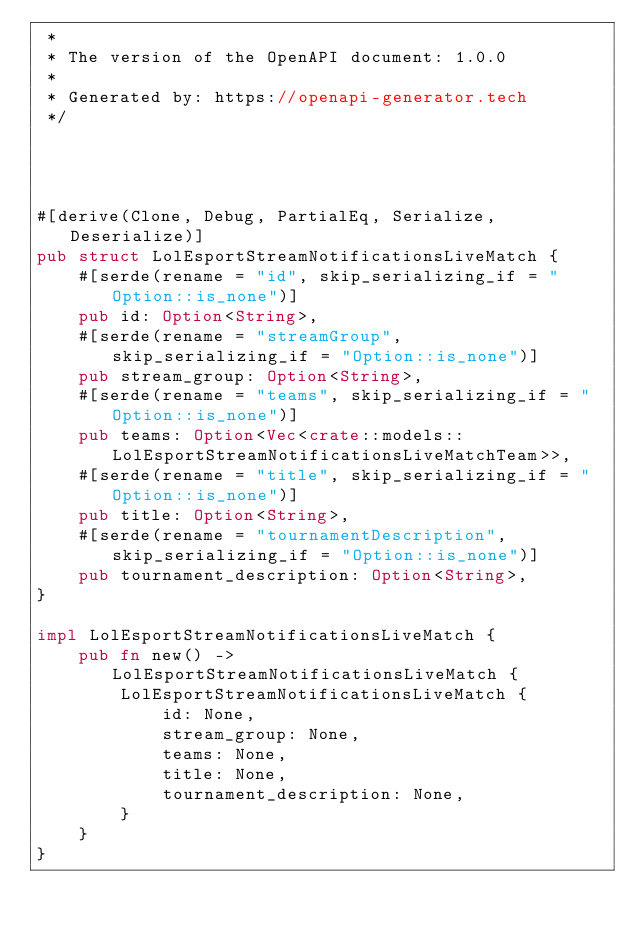<code> <loc_0><loc_0><loc_500><loc_500><_Rust_> *
 * The version of the OpenAPI document: 1.0.0
 * 
 * Generated by: https://openapi-generator.tech
 */




#[derive(Clone, Debug, PartialEq, Serialize, Deserialize)]
pub struct LolEsportStreamNotificationsLiveMatch {
    #[serde(rename = "id", skip_serializing_if = "Option::is_none")]
    pub id: Option<String>,
    #[serde(rename = "streamGroup", skip_serializing_if = "Option::is_none")]
    pub stream_group: Option<String>,
    #[serde(rename = "teams", skip_serializing_if = "Option::is_none")]
    pub teams: Option<Vec<crate::models::LolEsportStreamNotificationsLiveMatchTeam>>,
    #[serde(rename = "title", skip_serializing_if = "Option::is_none")]
    pub title: Option<String>,
    #[serde(rename = "tournamentDescription", skip_serializing_if = "Option::is_none")]
    pub tournament_description: Option<String>,
}

impl LolEsportStreamNotificationsLiveMatch {
    pub fn new() -> LolEsportStreamNotificationsLiveMatch {
        LolEsportStreamNotificationsLiveMatch {
            id: None,
            stream_group: None,
            teams: None,
            title: None,
            tournament_description: None,
        }
    }
}


</code> 